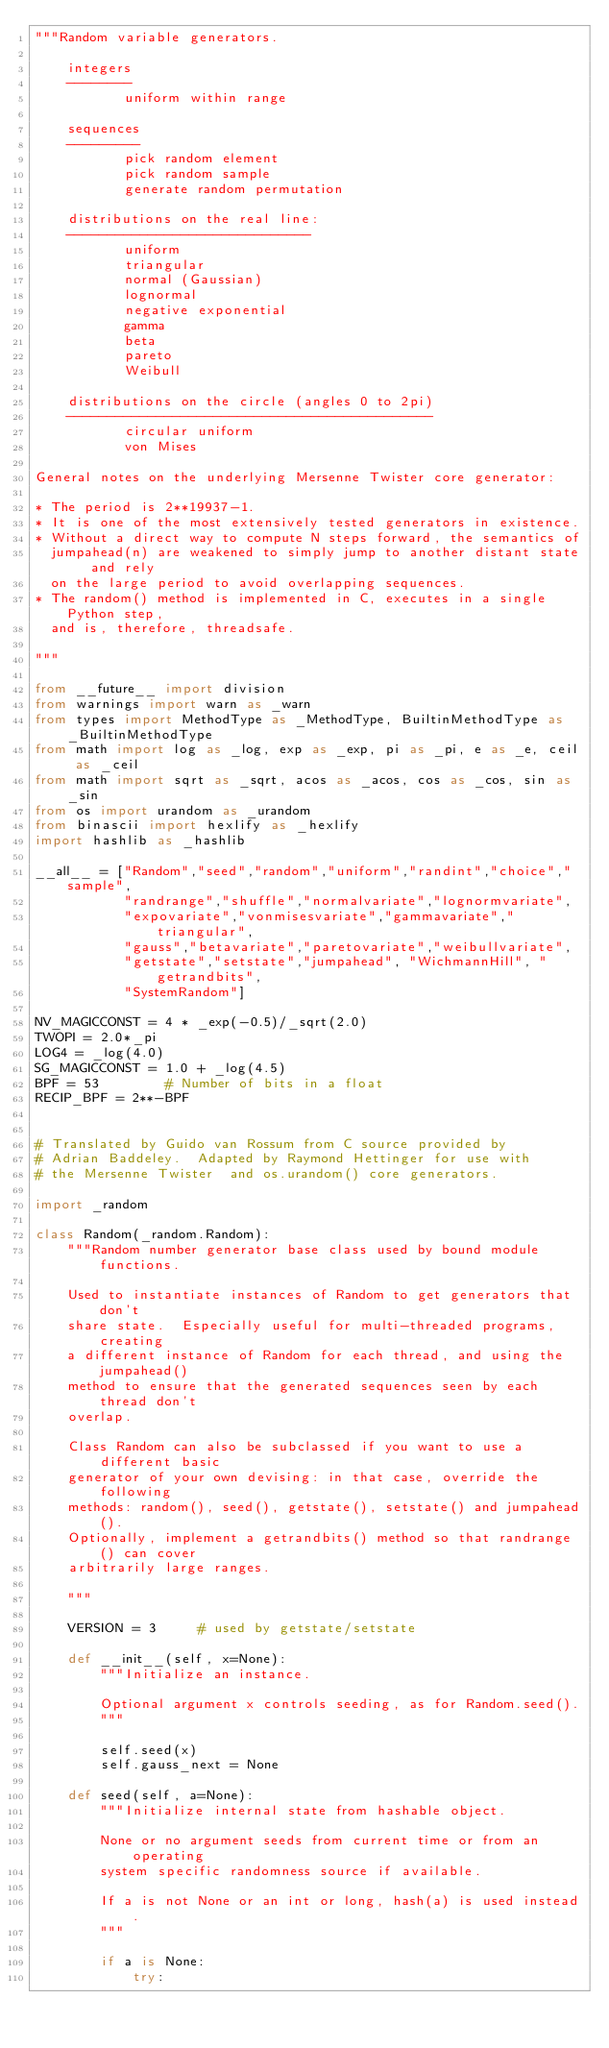<code> <loc_0><loc_0><loc_500><loc_500><_Python_>"""Random variable generators.

    integers
    --------
           uniform within range

    sequences
    ---------
           pick random element
           pick random sample
           generate random permutation

    distributions on the real line:
    ------------------------------
           uniform
           triangular
           normal (Gaussian)
           lognormal
           negative exponential
           gamma
           beta
           pareto
           Weibull

    distributions on the circle (angles 0 to 2pi)
    ---------------------------------------------
           circular uniform
           von Mises

General notes on the underlying Mersenne Twister core generator:

* The period is 2**19937-1.
* It is one of the most extensively tested generators in existence.
* Without a direct way to compute N steps forward, the semantics of
  jumpahead(n) are weakened to simply jump to another distant state and rely
  on the large period to avoid overlapping sequences.
* The random() method is implemented in C, executes in a single Python step,
  and is, therefore, threadsafe.

"""

from __future__ import division
from warnings import warn as _warn
from types import MethodType as _MethodType, BuiltinMethodType as _BuiltinMethodType
from math import log as _log, exp as _exp, pi as _pi, e as _e, ceil as _ceil
from math import sqrt as _sqrt, acos as _acos, cos as _cos, sin as _sin
from os import urandom as _urandom
from binascii import hexlify as _hexlify
import hashlib as _hashlib

__all__ = ["Random","seed","random","uniform","randint","choice","sample",
           "randrange","shuffle","normalvariate","lognormvariate",
           "expovariate","vonmisesvariate","gammavariate","triangular",
           "gauss","betavariate","paretovariate","weibullvariate",
           "getstate","setstate","jumpahead", "WichmannHill", "getrandbits",
           "SystemRandom"]

NV_MAGICCONST = 4 * _exp(-0.5)/_sqrt(2.0)
TWOPI = 2.0*_pi
LOG4 = _log(4.0)
SG_MAGICCONST = 1.0 + _log(4.5)
BPF = 53        # Number of bits in a float
RECIP_BPF = 2**-BPF


# Translated by Guido van Rossum from C source provided by
# Adrian Baddeley.  Adapted by Raymond Hettinger for use with
# the Mersenne Twister  and os.urandom() core generators.

import _random

class Random(_random.Random):
    """Random number generator base class used by bound module functions.

    Used to instantiate instances of Random to get generators that don't
    share state.  Especially useful for multi-threaded programs, creating
    a different instance of Random for each thread, and using the jumpahead()
    method to ensure that the generated sequences seen by each thread don't
    overlap.

    Class Random can also be subclassed if you want to use a different basic
    generator of your own devising: in that case, override the following
    methods: random(), seed(), getstate(), setstate() and jumpahead().
    Optionally, implement a getrandbits() method so that randrange() can cover
    arbitrarily large ranges.

    """

    VERSION = 3     # used by getstate/setstate

    def __init__(self, x=None):
        """Initialize an instance.

        Optional argument x controls seeding, as for Random.seed().
        """

        self.seed(x)
        self.gauss_next = None

    def seed(self, a=None):
        """Initialize internal state from hashable object.

        None or no argument seeds from current time or from an operating
        system specific randomness source if available.

        If a is not None or an int or long, hash(a) is used instead.
        """

        if a is None:
            try:</code> 